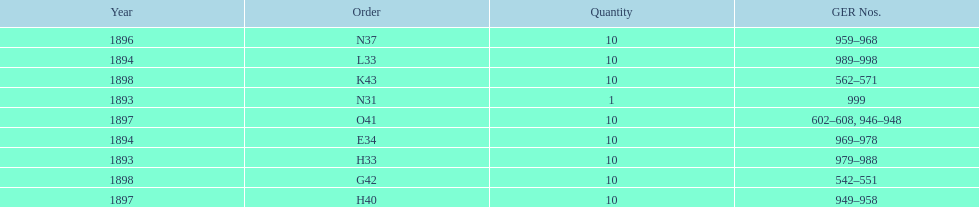Could you parse the entire table? {'header': ['Year', 'Order', 'Quantity', 'GER Nos.'], 'rows': [['1896', 'N37', '10', '959–968'], ['1894', 'L33', '10', '989–998'], ['1898', 'K43', '10', '562–571'], ['1893', 'N31', '1', '999'], ['1897', 'O41', '10', '602–608, 946–948'], ['1894', 'E34', '10', '969–978'], ['1893', 'H33', '10', '979–988'], ['1898', 'G42', '10', '542–551'], ['1897', 'H40', '10', '949–958']]} How many years are detailed? 5. 